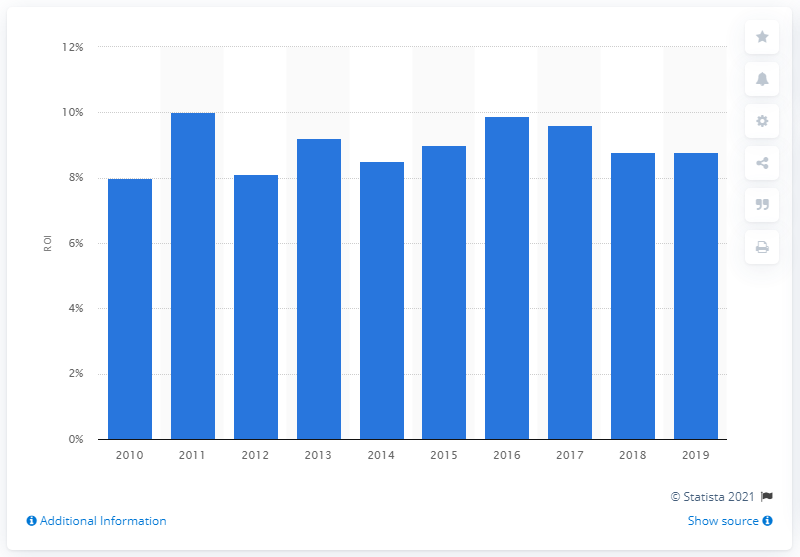Identify some key points in this picture. The return on investment in the beverage sector in 2019 was 8.8%. 